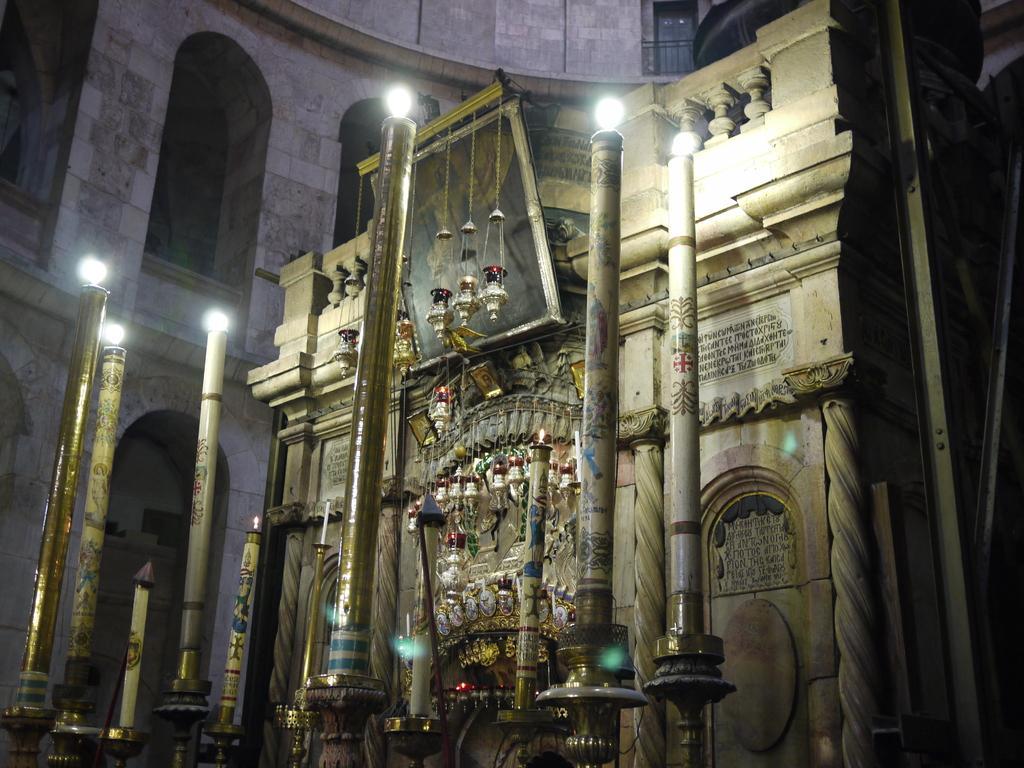Can you describe this image briefly? In this picture we can see a photo frame and some text on the wall, here we can see poles, lights, decorative objects and some objects. 